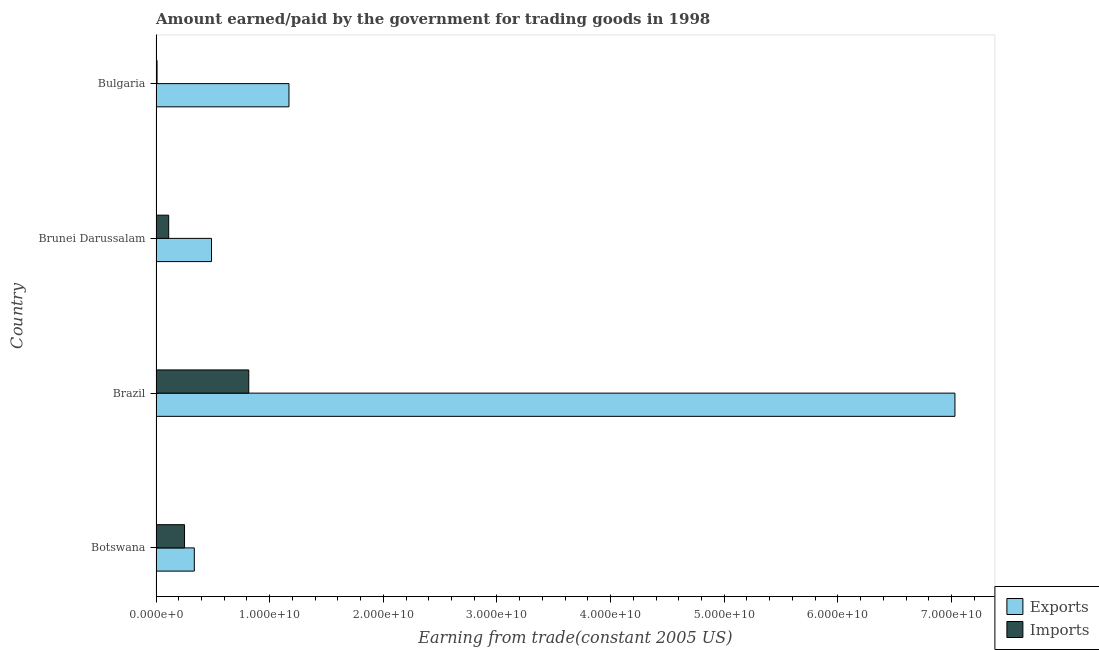How many different coloured bars are there?
Ensure brevity in your answer.  2. How many bars are there on the 4th tick from the top?
Provide a short and direct response. 2. How many bars are there on the 3rd tick from the bottom?
Provide a succinct answer. 2. In how many cases, is the number of bars for a given country not equal to the number of legend labels?
Keep it short and to the point. 0. What is the amount paid for imports in Brunei Darussalam?
Your answer should be compact. 1.11e+09. Across all countries, what is the maximum amount earned from exports?
Ensure brevity in your answer.  7.03e+1. Across all countries, what is the minimum amount earned from exports?
Your answer should be very brief. 3.37e+09. In which country was the amount paid for imports maximum?
Offer a terse response. Brazil. What is the total amount paid for imports in the graph?
Your answer should be very brief. 1.19e+1. What is the difference between the amount paid for imports in Brazil and that in Bulgaria?
Ensure brevity in your answer.  8.07e+09. What is the difference between the amount paid for imports in Bulgaria and the amount earned from exports in Brazil?
Keep it short and to the point. -7.02e+1. What is the average amount earned from exports per country?
Provide a short and direct response. 2.26e+1. What is the difference between the amount paid for imports and amount earned from exports in Bulgaria?
Keep it short and to the point. -1.16e+1. In how many countries, is the amount paid for imports greater than 38000000000 US$?
Offer a very short reply. 0. What is the ratio of the amount paid for imports in Brazil to that in Bulgaria?
Offer a terse response. 88.89. Is the difference between the amount paid for imports in Botswana and Brazil greater than the difference between the amount earned from exports in Botswana and Brazil?
Provide a short and direct response. Yes. What is the difference between the highest and the second highest amount earned from exports?
Provide a short and direct response. 5.86e+1. What is the difference between the highest and the lowest amount paid for imports?
Ensure brevity in your answer.  8.07e+09. In how many countries, is the amount earned from exports greater than the average amount earned from exports taken over all countries?
Ensure brevity in your answer.  1. What does the 2nd bar from the top in Botswana represents?
Offer a very short reply. Exports. What does the 2nd bar from the bottom in Botswana represents?
Make the answer very short. Imports. Are all the bars in the graph horizontal?
Ensure brevity in your answer.  Yes. How many countries are there in the graph?
Keep it short and to the point. 4. Are the values on the major ticks of X-axis written in scientific E-notation?
Provide a short and direct response. Yes. Does the graph contain grids?
Offer a terse response. No. What is the title of the graph?
Give a very brief answer. Amount earned/paid by the government for trading goods in 1998. Does "Female" appear as one of the legend labels in the graph?
Make the answer very short. No. What is the label or title of the X-axis?
Your response must be concise. Earning from trade(constant 2005 US). What is the Earning from trade(constant 2005 US) of Exports in Botswana?
Give a very brief answer. 3.37e+09. What is the Earning from trade(constant 2005 US) in Imports in Botswana?
Your answer should be very brief. 2.51e+09. What is the Earning from trade(constant 2005 US) in Exports in Brazil?
Make the answer very short. 7.03e+1. What is the Earning from trade(constant 2005 US) of Imports in Brazil?
Offer a terse response. 8.16e+09. What is the Earning from trade(constant 2005 US) of Exports in Brunei Darussalam?
Your answer should be very brief. 4.88e+09. What is the Earning from trade(constant 2005 US) in Imports in Brunei Darussalam?
Offer a terse response. 1.11e+09. What is the Earning from trade(constant 2005 US) of Exports in Bulgaria?
Offer a terse response. 1.17e+1. What is the Earning from trade(constant 2005 US) of Imports in Bulgaria?
Your answer should be very brief. 9.18e+07. Across all countries, what is the maximum Earning from trade(constant 2005 US) of Exports?
Your answer should be compact. 7.03e+1. Across all countries, what is the maximum Earning from trade(constant 2005 US) of Imports?
Provide a succinct answer. 8.16e+09. Across all countries, what is the minimum Earning from trade(constant 2005 US) in Exports?
Give a very brief answer. 3.37e+09. Across all countries, what is the minimum Earning from trade(constant 2005 US) of Imports?
Your response must be concise. 9.18e+07. What is the total Earning from trade(constant 2005 US) of Exports in the graph?
Your answer should be very brief. 9.03e+1. What is the total Earning from trade(constant 2005 US) in Imports in the graph?
Your answer should be very brief. 1.19e+1. What is the difference between the Earning from trade(constant 2005 US) in Exports in Botswana and that in Brazil?
Offer a terse response. -6.69e+1. What is the difference between the Earning from trade(constant 2005 US) of Imports in Botswana and that in Brazil?
Make the answer very short. -5.65e+09. What is the difference between the Earning from trade(constant 2005 US) in Exports in Botswana and that in Brunei Darussalam?
Your answer should be compact. -1.51e+09. What is the difference between the Earning from trade(constant 2005 US) in Imports in Botswana and that in Brunei Darussalam?
Offer a very short reply. 1.40e+09. What is the difference between the Earning from trade(constant 2005 US) of Exports in Botswana and that in Bulgaria?
Provide a succinct answer. -8.33e+09. What is the difference between the Earning from trade(constant 2005 US) in Imports in Botswana and that in Bulgaria?
Your response must be concise. 2.42e+09. What is the difference between the Earning from trade(constant 2005 US) of Exports in Brazil and that in Brunei Darussalam?
Your response must be concise. 6.54e+1. What is the difference between the Earning from trade(constant 2005 US) in Imports in Brazil and that in Brunei Darussalam?
Your answer should be very brief. 7.05e+09. What is the difference between the Earning from trade(constant 2005 US) in Exports in Brazil and that in Bulgaria?
Give a very brief answer. 5.86e+1. What is the difference between the Earning from trade(constant 2005 US) in Imports in Brazil and that in Bulgaria?
Your response must be concise. 8.07e+09. What is the difference between the Earning from trade(constant 2005 US) of Exports in Brunei Darussalam and that in Bulgaria?
Provide a succinct answer. -6.82e+09. What is the difference between the Earning from trade(constant 2005 US) in Imports in Brunei Darussalam and that in Bulgaria?
Your answer should be compact. 1.02e+09. What is the difference between the Earning from trade(constant 2005 US) in Exports in Botswana and the Earning from trade(constant 2005 US) in Imports in Brazil?
Make the answer very short. -4.79e+09. What is the difference between the Earning from trade(constant 2005 US) of Exports in Botswana and the Earning from trade(constant 2005 US) of Imports in Brunei Darussalam?
Keep it short and to the point. 2.26e+09. What is the difference between the Earning from trade(constant 2005 US) in Exports in Botswana and the Earning from trade(constant 2005 US) in Imports in Bulgaria?
Offer a very short reply. 3.28e+09. What is the difference between the Earning from trade(constant 2005 US) of Exports in Brazil and the Earning from trade(constant 2005 US) of Imports in Brunei Darussalam?
Your answer should be very brief. 6.92e+1. What is the difference between the Earning from trade(constant 2005 US) in Exports in Brazil and the Earning from trade(constant 2005 US) in Imports in Bulgaria?
Give a very brief answer. 7.02e+1. What is the difference between the Earning from trade(constant 2005 US) in Exports in Brunei Darussalam and the Earning from trade(constant 2005 US) in Imports in Bulgaria?
Provide a succinct answer. 4.79e+09. What is the average Earning from trade(constant 2005 US) in Exports per country?
Your answer should be compact. 2.26e+1. What is the average Earning from trade(constant 2005 US) of Imports per country?
Your response must be concise. 2.97e+09. What is the difference between the Earning from trade(constant 2005 US) in Exports and Earning from trade(constant 2005 US) in Imports in Botswana?
Offer a terse response. 8.61e+08. What is the difference between the Earning from trade(constant 2005 US) in Exports and Earning from trade(constant 2005 US) in Imports in Brazil?
Your response must be concise. 6.21e+1. What is the difference between the Earning from trade(constant 2005 US) of Exports and Earning from trade(constant 2005 US) of Imports in Brunei Darussalam?
Your answer should be very brief. 3.77e+09. What is the difference between the Earning from trade(constant 2005 US) of Exports and Earning from trade(constant 2005 US) of Imports in Bulgaria?
Give a very brief answer. 1.16e+1. What is the ratio of the Earning from trade(constant 2005 US) in Exports in Botswana to that in Brazil?
Provide a short and direct response. 0.05. What is the ratio of the Earning from trade(constant 2005 US) of Imports in Botswana to that in Brazil?
Provide a short and direct response. 0.31. What is the ratio of the Earning from trade(constant 2005 US) in Exports in Botswana to that in Brunei Darussalam?
Your response must be concise. 0.69. What is the ratio of the Earning from trade(constant 2005 US) in Imports in Botswana to that in Brunei Darussalam?
Offer a very short reply. 2.25. What is the ratio of the Earning from trade(constant 2005 US) in Exports in Botswana to that in Bulgaria?
Offer a terse response. 0.29. What is the ratio of the Earning from trade(constant 2005 US) of Imports in Botswana to that in Bulgaria?
Provide a succinct answer. 27.33. What is the ratio of the Earning from trade(constant 2005 US) of Exports in Brazil to that in Brunei Darussalam?
Your answer should be very brief. 14.4. What is the ratio of the Earning from trade(constant 2005 US) in Imports in Brazil to that in Brunei Darussalam?
Offer a very short reply. 7.33. What is the ratio of the Earning from trade(constant 2005 US) of Exports in Brazil to that in Bulgaria?
Your answer should be compact. 6.01. What is the ratio of the Earning from trade(constant 2005 US) of Imports in Brazil to that in Bulgaria?
Ensure brevity in your answer.  88.89. What is the ratio of the Earning from trade(constant 2005 US) of Exports in Brunei Darussalam to that in Bulgaria?
Give a very brief answer. 0.42. What is the ratio of the Earning from trade(constant 2005 US) in Imports in Brunei Darussalam to that in Bulgaria?
Offer a terse response. 12.13. What is the difference between the highest and the second highest Earning from trade(constant 2005 US) in Exports?
Offer a very short reply. 5.86e+1. What is the difference between the highest and the second highest Earning from trade(constant 2005 US) of Imports?
Your response must be concise. 5.65e+09. What is the difference between the highest and the lowest Earning from trade(constant 2005 US) of Exports?
Offer a very short reply. 6.69e+1. What is the difference between the highest and the lowest Earning from trade(constant 2005 US) in Imports?
Offer a terse response. 8.07e+09. 